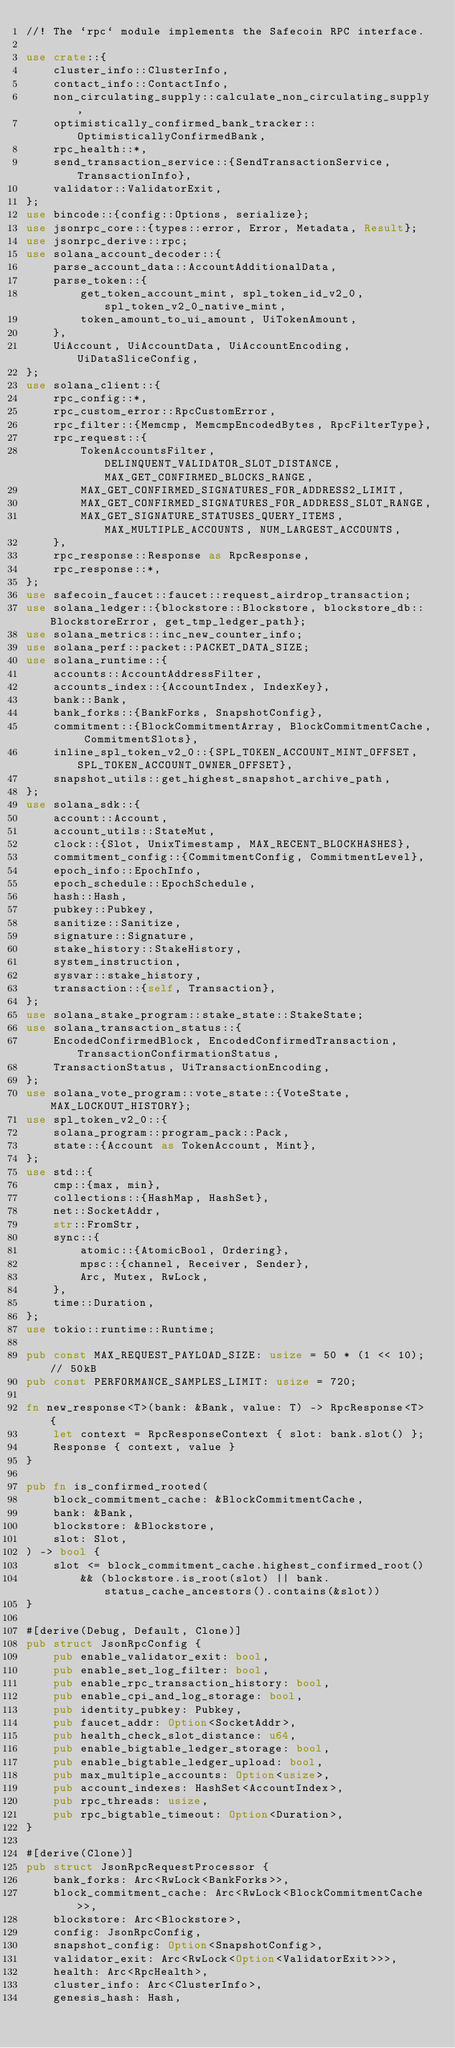Convert code to text. <code><loc_0><loc_0><loc_500><loc_500><_Rust_>//! The `rpc` module implements the Safecoin RPC interface.

use crate::{
    cluster_info::ClusterInfo,
    contact_info::ContactInfo,
    non_circulating_supply::calculate_non_circulating_supply,
    optimistically_confirmed_bank_tracker::OptimisticallyConfirmedBank,
    rpc_health::*,
    send_transaction_service::{SendTransactionService, TransactionInfo},
    validator::ValidatorExit,
};
use bincode::{config::Options, serialize};
use jsonrpc_core::{types::error, Error, Metadata, Result};
use jsonrpc_derive::rpc;
use solana_account_decoder::{
    parse_account_data::AccountAdditionalData,
    parse_token::{
        get_token_account_mint, spl_token_id_v2_0, spl_token_v2_0_native_mint,
        token_amount_to_ui_amount, UiTokenAmount,
    },
    UiAccount, UiAccountData, UiAccountEncoding, UiDataSliceConfig,
};
use solana_client::{
    rpc_config::*,
    rpc_custom_error::RpcCustomError,
    rpc_filter::{Memcmp, MemcmpEncodedBytes, RpcFilterType},
    rpc_request::{
        TokenAccountsFilter, DELINQUENT_VALIDATOR_SLOT_DISTANCE, MAX_GET_CONFIRMED_BLOCKS_RANGE,
        MAX_GET_CONFIRMED_SIGNATURES_FOR_ADDRESS2_LIMIT,
        MAX_GET_CONFIRMED_SIGNATURES_FOR_ADDRESS_SLOT_RANGE,
        MAX_GET_SIGNATURE_STATUSES_QUERY_ITEMS, MAX_MULTIPLE_ACCOUNTS, NUM_LARGEST_ACCOUNTS,
    },
    rpc_response::Response as RpcResponse,
    rpc_response::*,
};
use safecoin_faucet::faucet::request_airdrop_transaction;
use solana_ledger::{blockstore::Blockstore, blockstore_db::BlockstoreError, get_tmp_ledger_path};
use solana_metrics::inc_new_counter_info;
use solana_perf::packet::PACKET_DATA_SIZE;
use solana_runtime::{
    accounts::AccountAddressFilter,
    accounts_index::{AccountIndex, IndexKey},
    bank::Bank,
    bank_forks::{BankForks, SnapshotConfig},
    commitment::{BlockCommitmentArray, BlockCommitmentCache, CommitmentSlots},
    inline_spl_token_v2_0::{SPL_TOKEN_ACCOUNT_MINT_OFFSET, SPL_TOKEN_ACCOUNT_OWNER_OFFSET},
    snapshot_utils::get_highest_snapshot_archive_path,
};
use solana_sdk::{
    account::Account,
    account_utils::StateMut,
    clock::{Slot, UnixTimestamp, MAX_RECENT_BLOCKHASHES},
    commitment_config::{CommitmentConfig, CommitmentLevel},
    epoch_info::EpochInfo,
    epoch_schedule::EpochSchedule,
    hash::Hash,
    pubkey::Pubkey,
    sanitize::Sanitize,
    signature::Signature,
    stake_history::StakeHistory,
    system_instruction,
    sysvar::stake_history,
    transaction::{self, Transaction},
};
use solana_stake_program::stake_state::StakeState;
use solana_transaction_status::{
    EncodedConfirmedBlock, EncodedConfirmedTransaction, TransactionConfirmationStatus,
    TransactionStatus, UiTransactionEncoding,
};
use solana_vote_program::vote_state::{VoteState, MAX_LOCKOUT_HISTORY};
use spl_token_v2_0::{
    solana_program::program_pack::Pack,
    state::{Account as TokenAccount, Mint},
};
use std::{
    cmp::{max, min},
    collections::{HashMap, HashSet},
    net::SocketAddr,
    str::FromStr,
    sync::{
        atomic::{AtomicBool, Ordering},
        mpsc::{channel, Receiver, Sender},
        Arc, Mutex, RwLock,
    },
    time::Duration,
};
use tokio::runtime::Runtime;

pub const MAX_REQUEST_PAYLOAD_SIZE: usize = 50 * (1 << 10); // 50kB
pub const PERFORMANCE_SAMPLES_LIMIT: usize = 720;

fn new_response<T>(bank: &Bank, value: T) -> RpcResponse<T> {
    let context = RpcResponseContext { slot: bank.slot() };
    Response { context, value }
}

pub fn is_confirmed_rooted(
    block_commitment_cache: &BlockCommitmentCache,
    bank: &Bank,
    blockstore: &Blockstore,
    slot: Slot,
) -> bool {
    slot <= block_commitment_cache.highest_confirmed_root()
        && (blockstore.is_root(slot) || bank.status_cache_ancestors().contains(&slot))
}

#[derive(Debug, Default, Clone)]
pub struct JsonRpcConfig {
    pub enable_validator_exit: bool,
    pub enable_set_log_filter: bool,
    pub enable_rpc_transaction_history: bool,
    pub enable_cpi_and_log_storage: bool,
    pub identity_pubkey: Pubkey,
    pub faucet_addr: Option<SocketAddr>,
    pub health_check_slot_distance: u64,
    pub enable_bigtable_ledger_storage: bool,
    pub enable_bigtable_ledger_upload: bool,
    pub max_multiple_accounts: Option<usize>,
    pub account_indexes: HashSet<AccountIndex>,
    pub rpc_threads: usize,
    pub rpc_bigtable_timeout: Option<Duration>,
}

#[derive(Clone)]
pub struct JsonRpcRequestProcessor {
    bank_forks: Arc<RwLock<BankForks>>,
    block_commitment_cache: Arc<RwLock<BlockCommitmentCache>>,
    blockstore: Arc<Blockstore>,
    config: JsonRpcConfig,
    snapshot_config: Option<SnapshotConfig>,
    validator_exit: Arc<RwLock<Option<ValidatorExit>>>,
    health: Arc<RpcHealth>,
    cluster_info: Arc<ClusterInfo>,
    genesis_hash: Hash,</code> 